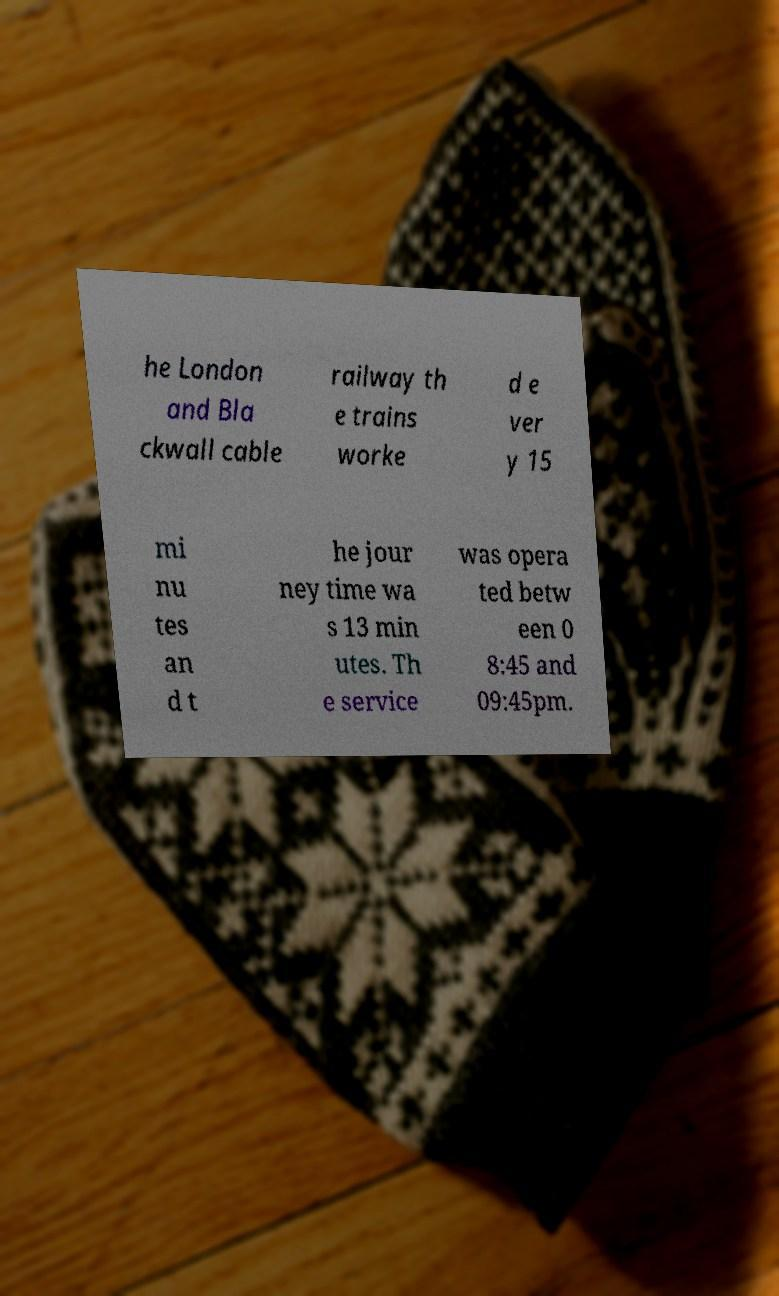I need the written content from this picture converted into text. Can you do that? he London and Bla ckwall cable railway th e trains worke d e ver y 15 mi nu tes an d t he jour ney time wa s 13 min utes. Th e service was opera ted betw een 0 8:45 and 09:45pm. 